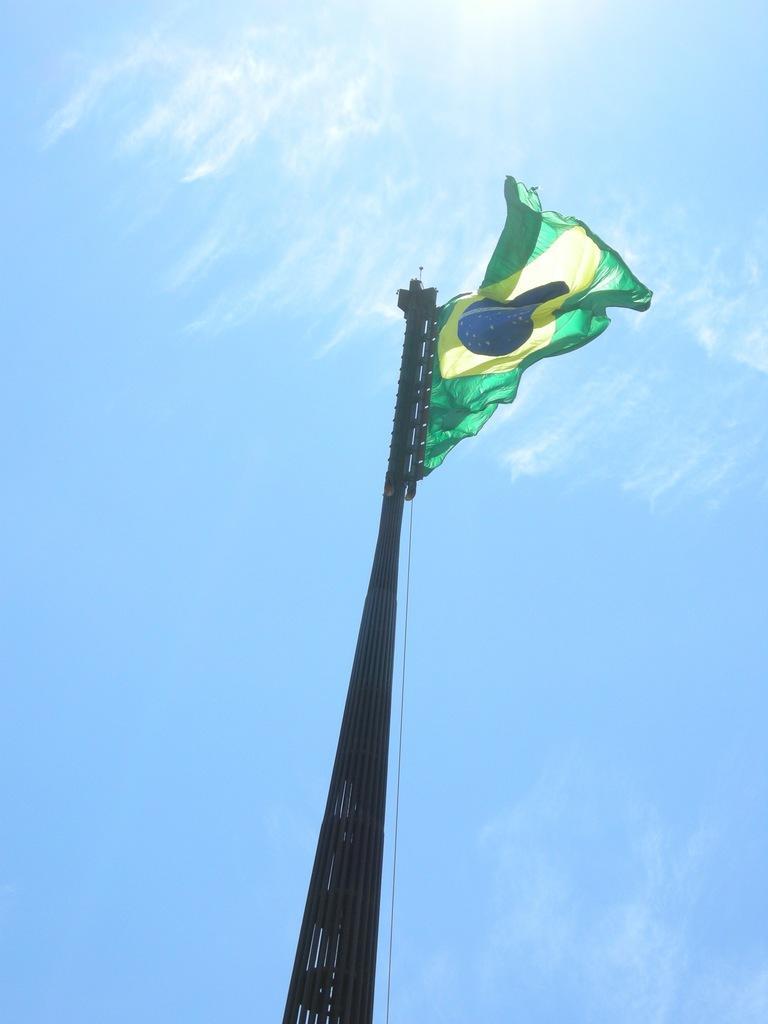Can you describe this image briefly? In the image we can see the flag attached to the pole and the pale blue sky. 